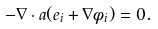<formula> <loc_0><loc_0><loc_500><loc_500>- \nabla \cdot a ( e _ { i } + \nabla \phi _ { i } ) = 0 .</formula> 